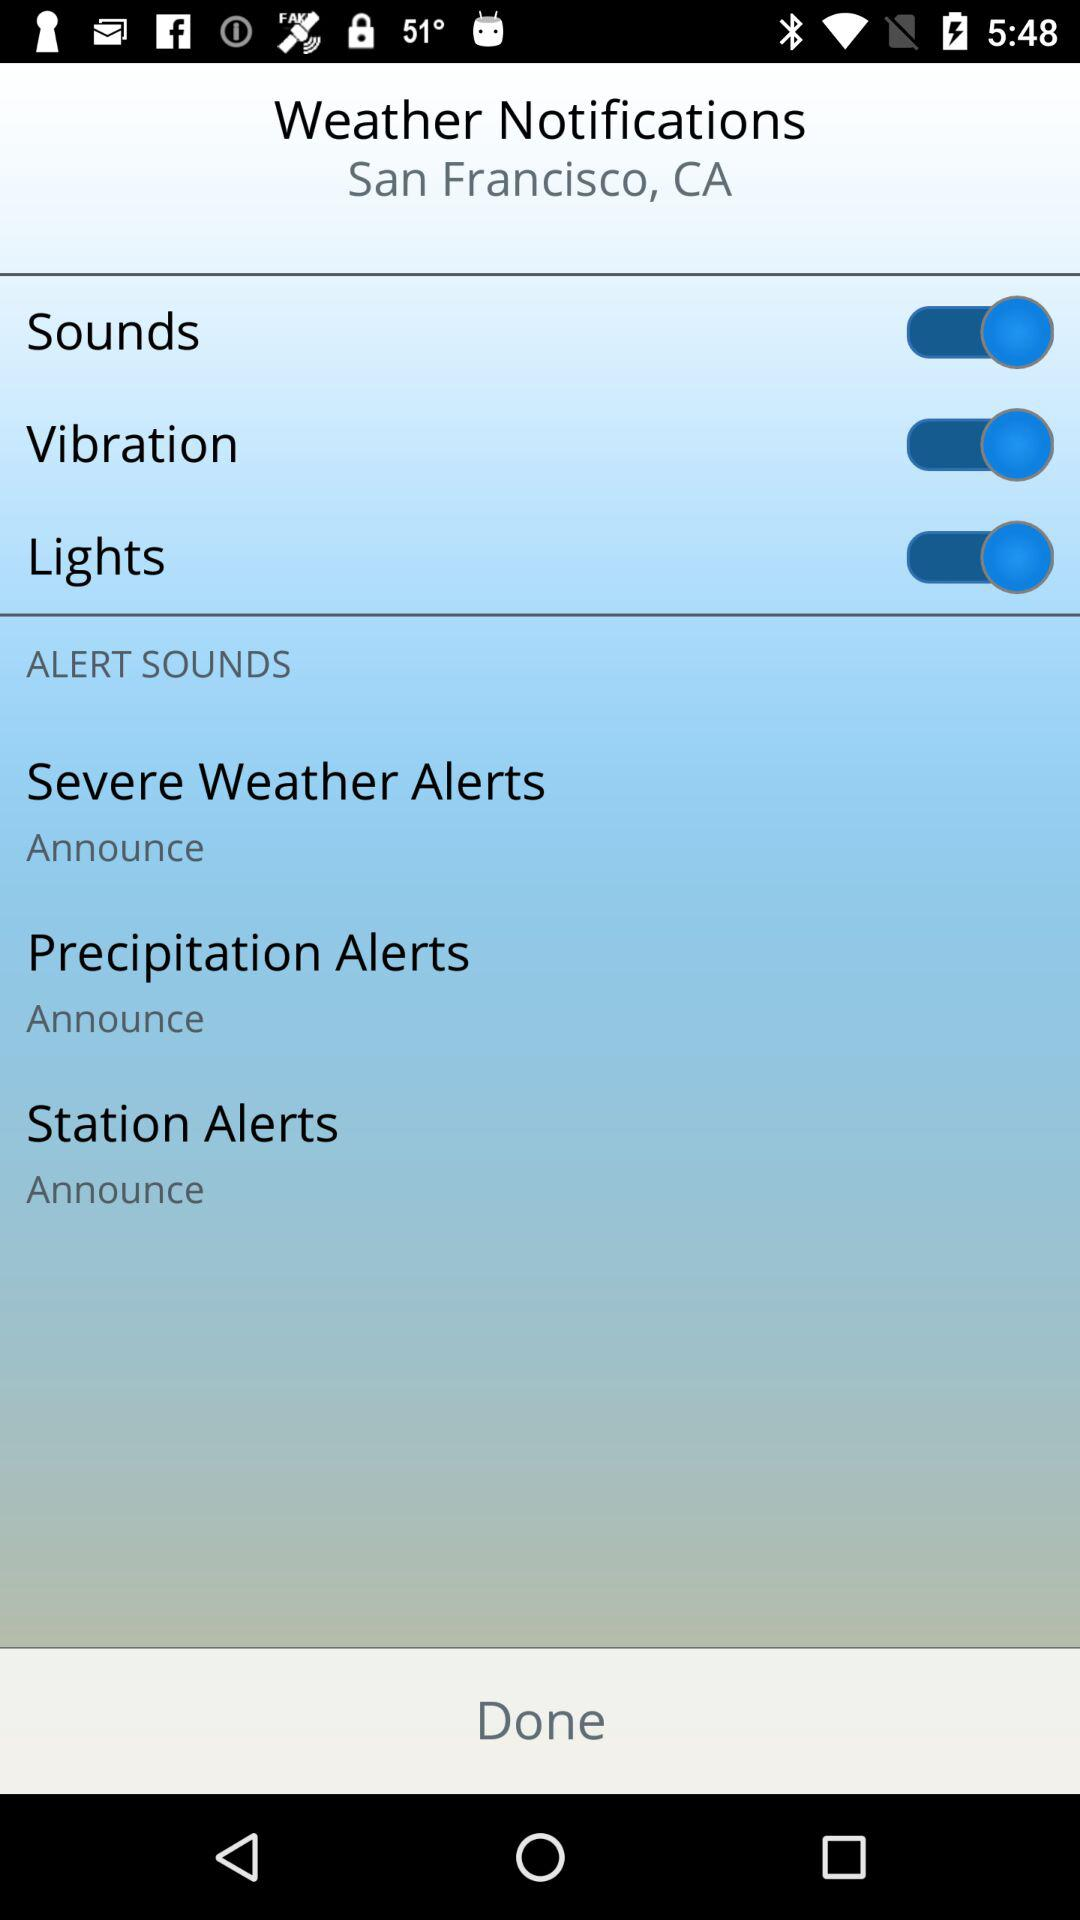Is "Lights" enabled or disabled?
Answer the question using a single word or phrase. "Lights" is enabled. 